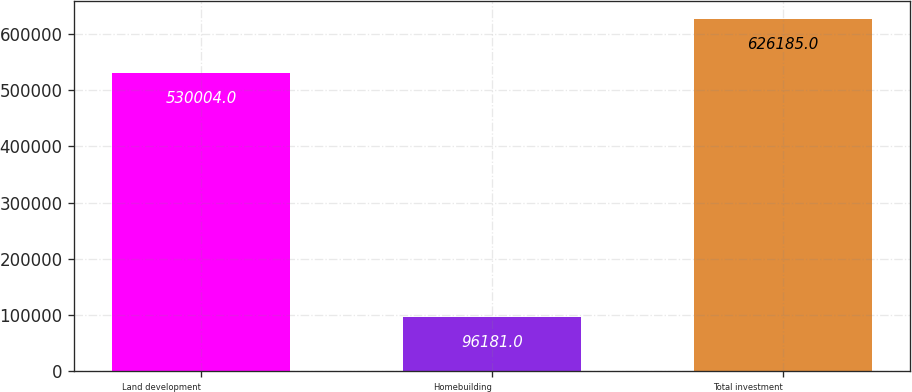Convert chart. <chart><loc_0><loc_0><loc_500><loc_500><bar_chart><fcel>Land development<fcel>Homebuilding<fcel>Total investment<nl><fcel>530004<fcel>96181<fcel>626185<nl></chart> 